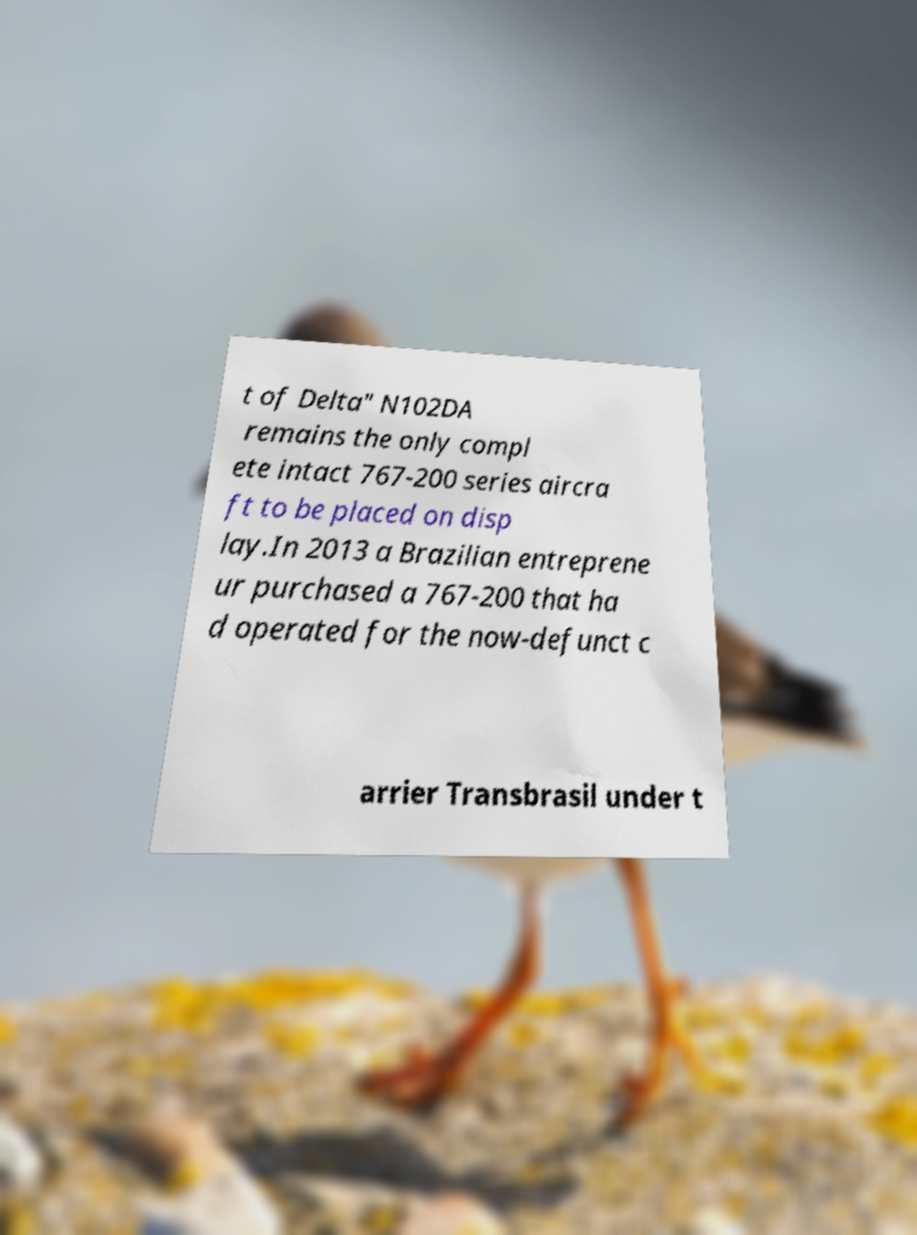I need the written content from this picture converted into text. Can you do that? t of Delta" N102DA remains the only compl ete intact 767-200 series aircra ft to be placed on disp lay.In 2013 a Brazilian entreprene ur purchased a 767-200 that ha d operated for the now-defunct c arrier Transbrasil under t 